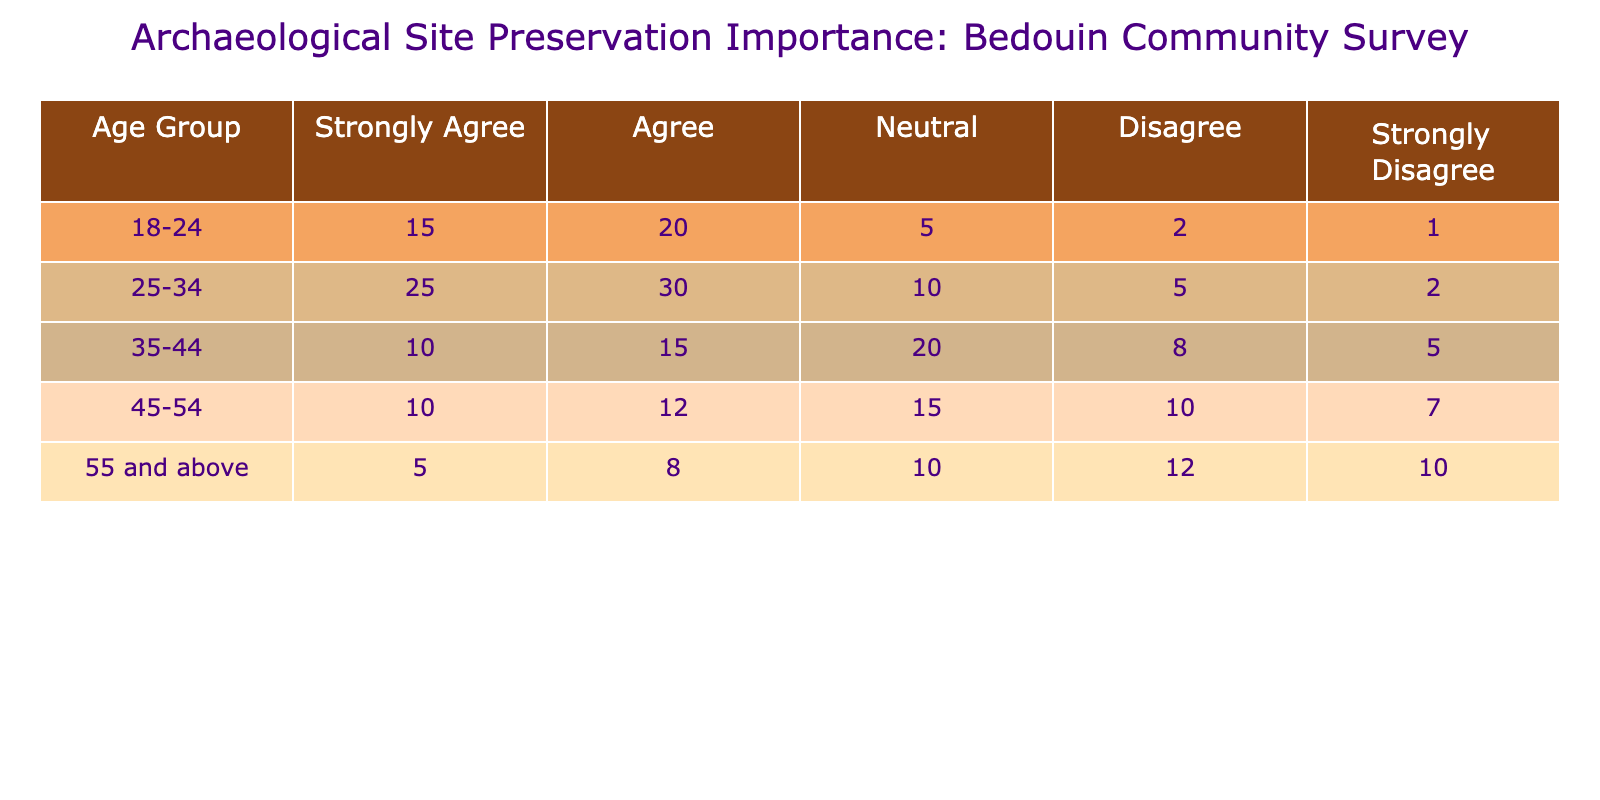What percentage of the 25-34 age group strongly agrees with the importance of archaeological site preservation? In the 25-34 age group, 25 individuals strongly agree, and the total responses for this age group can be calculated by summing all response categories: 25 + 30 + 10 + 5 + 2 = 72. To find the percentage, we use (25/72) * 100 ≈ 34.72%.
Answer: Approximately 34.72% What is the total number of respondents who disagree with site preservation in the 18-24 age group? The disagreement in the 18-24 age group consists of two categories: 2 respondents disagree and 1 strongly disagree. Therefore, the total number is 2 + 1 = 3.
Answer: 3 Which age group has the highest number of respondents who agree with the importance of site preservation? By examining the "Agree" column, we find the following values for agreement: 20 (18-24), 30 (25-34), 15 (35-44), 12 (45-54), and 8 (55 and above). The highest value is 30 from the 25-34 age group.
Answer: 25-34 What is the overall percentage of respondents who show neutrality towards site preservation across all age groups? First, we calculate the total number of neutral responses by summing the neutral values from all age groups: 5 + 10 + 20 + 15 + 10 = 70. Then, we find the overall number of respondents, which is the sum of all responses: 15 + 20 + 5 + 2 + 25 + 30 + 10 + 5 + 10 + 12 + 10 =  4 + 72 = 75. The percentage is (70/75) * 100 = 93.33%.
Answer: 93.33% Is there an age group where no respondents chose the "Strongly Disagree" option? Reviewing the "Strongly Disagree" column reveals the following: 1 (18-24), 2 (25-34), 5 (35-44), 7 (45-54), and 10 (55 and above). Each age group has at least one respondent in this category, meaning no age group can claim no "Strongly Disagree" responses.
Answer: No What is the difference in the number of "Strongly Agree" responses between the 18-24 and 45-54 age groups? The "Strongly Agree" responses are as follows: 15 (18-24) and 10 (45-54). The difference is calculated by subtracting the lesser from the greater: 15 - 10 = 5.
Answer: 5 